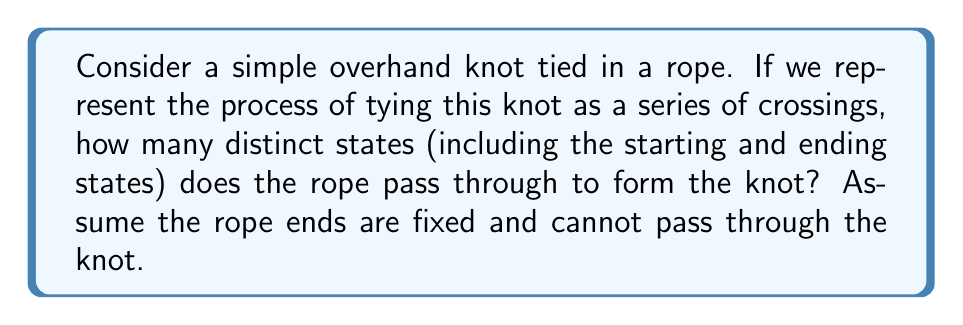Solve this math problem. To approach this problem, let's break down the process of tying an overhand knot:

1. Start with a straight rope (initial state).

2. Form a loop by crossing one end of the rope over the other. This creates the first crossing (state 2).

3. Pass the active end of the rope through the loop. This creates a second crossing (state 3).

4. Pull the knot tight to complete the overhand knot (final state).

Each of these steps represents a distinct state of the rope. The key insight is that each crossing of the rope creates a new state, and the initial and final states are also counted.

In group theory terms, we can consider each state as an element in the group of knot configurations. The operation that takes us from one state to another (crossing the rope) can be thought of as a generator of the group.

The overhand knot, being one of the simplest knots, has a minimal number of crossings required to form it. This sequence of states forms a simple chain in the group, where each element (state) is connected to the next by a single operation (crossing).

Counting the states:
1. Initial straight rope
2. First crossing
3. Second crossing
4. Final tightened knot

Therefore, the rope passes through 4 distinct states to form the overhand knot.
Answer: 4 distinct states 